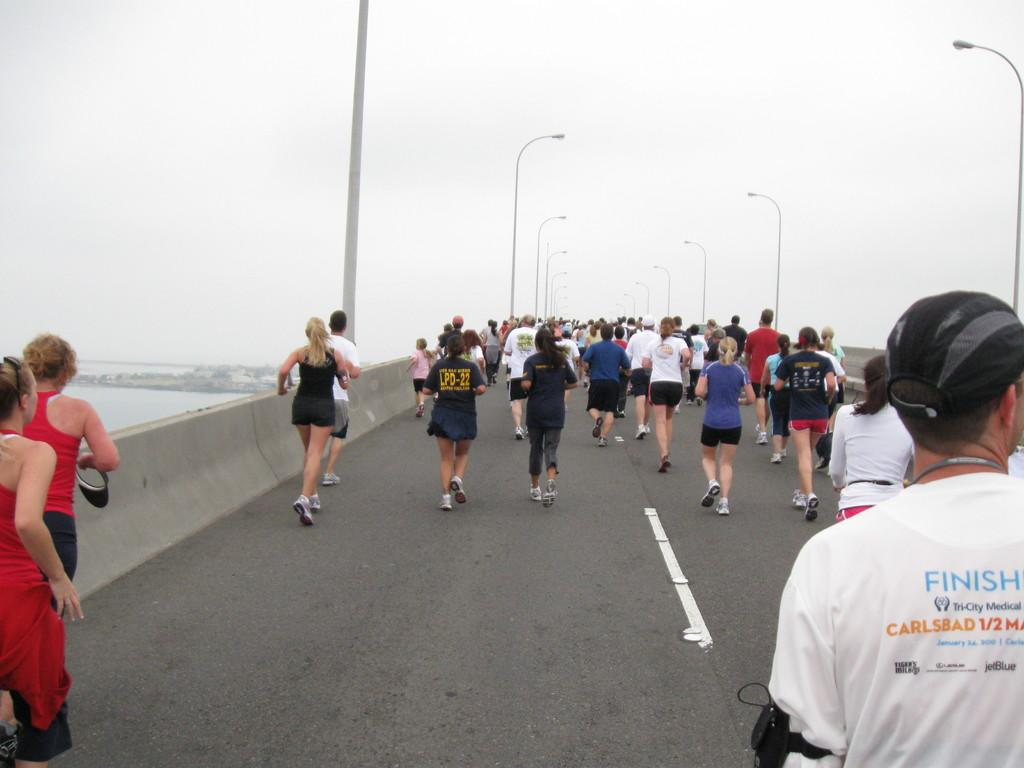What are the people in the image doing? There is a group of people running in the image. Where are the people running? The people are running on a flyover. What can be seen in the image besides the people running? There are poles, lights, trees, water, and the sky visible in the image. Can you tell me how many toes the people have in the image? There is no information about the people's toes in the image, as it focuses on their running activity. 